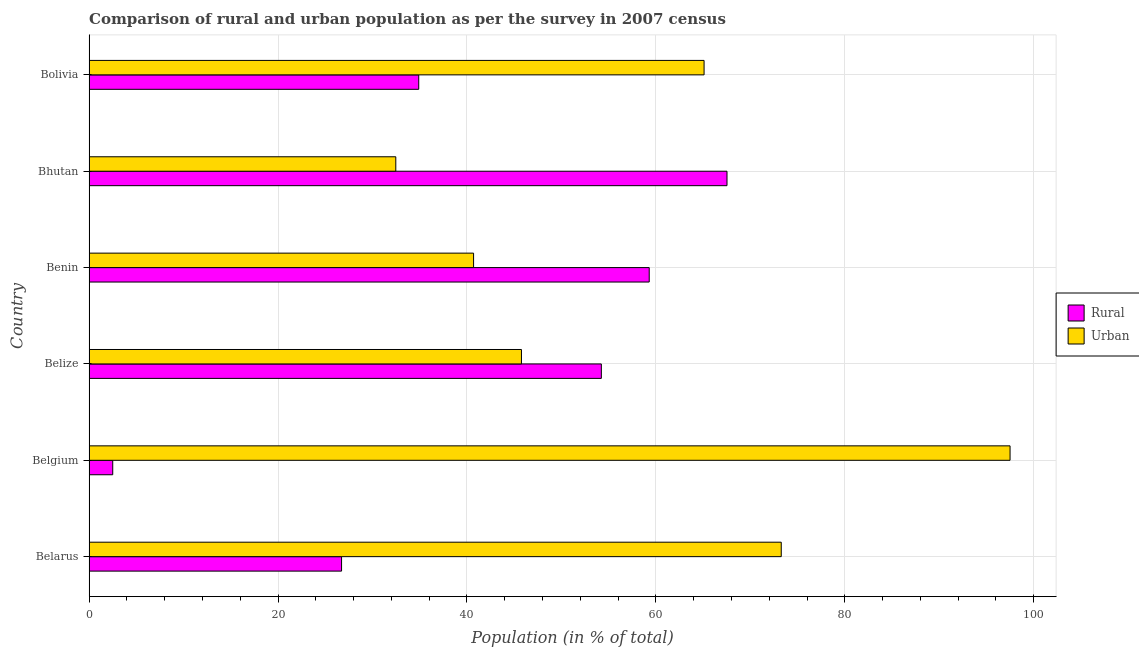How many different coloured bars are there?
Provide a succinct answer. 2. Are the number of bars per tick equal to the number of legend labels?
Offer a terse response. Yes. Are the number of bars on each tick of the Y-axis equal?
Keep it short and to the point. Yes. How many bars are there on the 1st tick from the top?
Provide a succinct answer. 2. What is the label of the 6th group of bars from the top?
Give a very brief answer. Belarus. What is the urban population in Belize?
Offer a very short reply. 45.77. Across all countries, what is the maximum urban population?
Ensure brevity in your answer.  97.5. Across all countries, what is the minimum rural population?
Your answer should be compact. 2.5. In which country was the rural population maximum?
Give a very brief answer. Bhutan. In which country was the urban population minimum?
Ensure brevity in your answer.  Bhutan. What is the total rural population in the graph?
Your answer should be very brief. 245.18. What is the difference between the rural population in Belize and that in Benin?
Make the answer very short. -5.07. What is the difference between the rural population in Bhutan and the urban population in Bolivia?
Offer a terse response. 2.43. What is the average urban population per country?
Make the answer very short. 59.14. What is the difference between the urban population and rural population in Belarus?
Offer a very short reply. 46.55. In how many countries, is the urban population greater than 32 %?
Keep it short and to the point. 6. What is the ratio of the urban population in Belgium to that in Belize?
Make the answer very short. 2.13. What is the difference between the highest and the second highest urban population?
Make the answer very short. 24.22. What is the difference between the highest and the lowest rural population?
Your response must be concise. 65.03. Is the sum of the rural population in Belarus and Belgium greater than the maximum urban population across all countries?
Provide a short and direct response. No. What does the 2nd bar from the top in Belarus represents?
Your answer should be very brief. Rural. What does the 2nd bar from the bottom in Bhutan represents?
Provide a short and direct response. Urban. Are all the bars in the graph horizontal?
Keep it short and to the point. Yes. How many countries are there in the graph?
Offer a very short reply. 6. What is the difference between two consecutive major ticks on the X-axis?
Offer a very short reply. 20. Are the values on the major ticks of X-axis written in scientific E-notation?
Your response must be concise. No. Does the graph contain any zero values?
Offer a terse response. No. Does the graph contain grids?
Your answer should be very brief. Yes. What is the title of the graph?
Make the answer very short. Comparison of rural and urban population as per the survey in 2007 census. What is the label or title of the X-axis?
Keep it short and to the point. Population (in % of total). What is the label or title of the Y-axis?
Provide a succinct answer. Country. What is the Population (in % of total) of Rural in Belarus?
Make the answer very short. 26.73. What is the Population (in % of total) in Urban in Belarus?
Your answer should be very brief. 73.27. What is the Population (in % of total) in Rural in Belgium?
Offer a terse response. 2.5. What is the Population (in % of total) of Urban in Belgium?
Offer a terse response. 97.5. What is the Population (in % of total) of Rural in Belize?
Your response must be concise. 54.23. What is the Population (in % of total) of Urban in Belize?
Your answer should be compact. 45.77. What is the Population (in % of total) in Rural in Benin?
Ensure brevity in your answer.  59.3. What is the Population (in % of total) of Urban in Benin?
Your response must be concise. 40.7. What is the Population (in % of total) in Rural in Bhutan?
Provide a succinct answer. 67.53. What is the Population (in % of total) of Urban in Bhutan?
Your response must be concise. 32.47. What is the Population (in % of total) in Rural in Bolivia?
Your answer should be compact. 34.9. What is the Population (in % of total) in Urban in Bolivia?
Keep it short and to the point. 65.1. Across all countries, what is the maximum Population (in % of total) of Rural?
Offer a terse response. 67.53. Across all countries, what is the maximum Population (in % of total) of Urban?
Give a very brief answer. 97.5. Across all countries, what is the minimum Population (in % of total) in Rural?
Give a very brief answer. 2.5. Across all countries, what is the minimum Population (in % of total) of Urban?
Give a very brief answer. 32.47. What is the total Population (in % of total) in Rural in the graph?
Your answer should be compact. 245.18. What is the total Population (in % of total) of Urban in the graph?
Provide a short and direct response. 354.82. What is the difference between the Population (in % of total) of Rural in Belarus and that in Belgium?
Provide a short and direct response. 24.22. What is the difference between the Population (in % of total) in Urban in Belarus and that in Belgium?
Make the answer very short. -24.22. What is the difference between the Population (in % of total) of Rural in Belarus and that in Belize?
Ensure brevity in your answer.  -27.5. What is the difference between the Population (in % of total) of Urban in Belarus and that in Belize?
Ensure brevity in your answer.  27.5. What is the difference between the Population (in % of total) in Rural in Belarus and that in Benin?
Offer a very short reply. -32.57. What is the difference between the Population (in % of total) of Urban in Belarus and that in Benin?
Provide a short and direct response. 32.57. What is the difference between the Population (in % of total) in Rural in Belarus and that in Bhutan?
Give a very brief answer. -40.8. What is the difference between the Population (in % of total) of Urban in Belarus and that in Bhutan?
Offer a very short reply. 40.8. What is the difference between the Population (in % of total) of Rural in Belarus and that in Bolivia?
Offer a terse response. -8.17. What is the difference between the Population (in % of total) in Urban in Belarus and that in Bolivia?
Offer a very short reply. 8.17. What is the difference between the Population (in % of total) in Rural in Belgium and that in Belize?
Make the answer very short. -51.73. What is the difference between the Population (in % of total) in Urban in Belgium and that in Belize?
Keep it short and to the point. 51.73. What is the difference between the Population (in % of total) of Rural in Belgium and that in Benin?
Offer a very short reply. -56.79. What is the difference between the Population (in % of total) of Urban in Belgium and that in Benin?
Your answer should be compact. 56.79. What is the difference between the Population (in % of total) in Rural in Belgium and that in Bhutan?
Provide a short and direct response. -65.03. What is the difference between the Population (in % of total) in Urban in Belgium and that in Bhutan?
Provide a succinct answer. 65.03. What is the difference between the Population (in % of total) in Rural in Belgium and that in Bolivia?
Provide a succinct answer. -32.39. What is the difference between the Population (in % of total) in Urban in Belgium and that in Bolivia?
Ensure brevity in your answer.  32.39. What is the difference between the Population (in % of total) of Rural in Belize and that in Benin?
Offer a very short reply. -5.07. What is the difference between the Population (in % of total) of Urban in Belize and that in Benin?
Offer a terse response. 5.07. What is the difference between the Population (in % of total) in Rural in Belize and that in Bhutan?
Offer a terse response. -13.3. What is the difference between the Population (in % of total) of Urban in Belize and that in Bhutan?
Offer a very short reply. 13.3. What is the difference between the Population (in % of total) of Rural in Belize and that in Bolivia?
Make the answer very short. 19.33. What is the difference between the Population (in % of total) in Urban in Belize and that in Bolivia?
Your response must be concise. -19.33. What is the difference between the Population (in % of total) of Rural in Benin and that in Bhutan?
Ensure brevity in your answer.  -8.23. What is the difference between the Population (in % of total) in Urban in Benin and that in Bhutan?
Offer a very short reply. 8.23. What is the difference between the Population (in % of total) in Rural in Benin and that in Bolivia?
Provide a short and direct response. 24.4. What is the difference between the Population (in % of total) in Urban in Benin and that in Bolivia?
Provide a succinct answer. -24.4. What is the difference between the Population (in % of total) in Rural in Bhutan and that in Bolivia?
Provide a succinct answer. 32.63. What is the difference between the Population (in % of total) of Urban in Bhutan and that in Bolivia?
Your answer should be compact. -32.63. What is the difference between the Population (in % of total) in Rural in Belarus and the Population (in % of total) in Urban in Belgium?
Provide a succinct answer. -70.77. What is the difference between the Population (in % of total) of Rural in Belarus and the Population (in % of total) of Urban in Belize?
Provide a short and direct response. -19.04. What is the difference between the Population (in % of total) of Rural in Belarus and the Population (in % of total) of Urban in Benin?
Offer a terse response. -13.98. What is the difference between the Population (in % of total) of Rural in Belarus and the Population (in % of total) of Urban in Bhutan?
Your answer should be compact. -5.74. What is the difference between the Population (in % of total) in Rural in Belarus and the Population (in % of total) in Urban in Bolivia?
Offer a terse response. -38.38. What is the difference between the Population (in % of total) of Rural in Belgium and the Population (in % of total) of Urban in Belize?
Provide a succinct answer. -43.27. What is the difference between the Population (in % of total) of Rural in Belgium and the Population (in % of total) of Urban in Benin?
Offer a very short reply. -38.2. What is the difference between the Population (in % of total) in Rural in Belgium and the Population (in % of total) in Urban in Bhutan?
Offer a very short reply. -29.97. What is the difference between the Population (in % of total) in Rural in Belgium and the Population (in % of total) in Urban in Bolivia?
Offer a terse response. -62.6. What is the difference between the Population (in % of total) of Rural in Belize and the Population (in % of total) of Urban in Benin?
Offer a terse response. 13.53. What is the difference between the Population (in % of total) of Rural in Belize and the Population (in % of total) of Urban in Bhutan?
Ensure brevity in your answer.  21.76. What is the difference between the Population (in % of total) of Rural in Belize and the Population (in % of total) of Urban in Bolivia?
Ensure brevity in your answer.  -10.88. What is the difference between the Population (in % of total) of Rural in Benin and the Population (in % of total) of Urban in Bhutan?
Give a very brief answer. 26.83. What is the difference between the Population (in % of total) of Rural in Benin and the Population (in % of total) of Urban in Bolivia?
Your answer should be very brief. -5.81. What is the difference between the Population (in % of total) of Rural in Bhutan and the Population (in % of total) of Urban in Bolivia?
Your response must be concise. 2.43. What is the average Population (in % of total) of Rural per country?
Ensure brevity in your answer.  40.86. What is the average Population (in % of total) in Urban per country?
Give a very brief answer. 59.14. What is the difference between the Population (in % of total) of Rural and Population (in % of total) of Urban in Belarus?
Make the answer very short. -46.55. What is the difference between the Population (in % of total) in Rural and Population (in % of total) in Urban in Belgium?
Give a very brief answer. -94.99. What is the difference between the Population (in % of total) of Rural and Population (in % of total) of Urban in Belize?
Provide a short and direct response. 8.46. What is the difference between the Population (in % of total) of Rural and Population (in % of total) of Urban in Benin?
Provide a succinct answer. 18.59. What is the difference between the Population (in % of total) of Rural and Population (in % of total) of Urban in Bhutan?
Your answer should be very brief. 35.06. What is the difference between the Population (in % of total) of Rural and Population (in % of total) of Urban in Bolivia?
Offer a very short reply. -30.21. What is the ratio of the Population (in % of total) in Rural in Belarus to that in Belgium?
Provide a succinct answer. 10.68. What is the ratio of the Population (in % of total) of Urban in Belarus to that in Belgium?
Provide a short and direct response. 0.75. What is the ratio of the Population (in % of total) in Rural in Belarus to that in Belize?
Offer a terse response. 0.49. What is the ratio of the Population (in % of total) of Urban in Belarus to that in Belize?
Ensure brevity in your answer.  1.6. What is the ratio of the Population (in % of total) of Rural in Belarus to that in Benin?
Make the answer very short. 0.45. What is the ratio of the Population (in % of total) of Urban in Belarus to that in Benin?
Ensure brevity in your answer.  1.8. What is the ratio of the Population (in % of total) of Rural in Belarus to that in Bhutan?
Your answer should be compact. 0.4. What is the ratio of the Population (in % of total) of Urban in Belarus to that in Bhutan?
Offer a very short reply. 2.26. What is the ratio of the Population (in % of total) in Rural in Belarus to that in Bolivia?
Make the answer very short. 0.77. What is the ratio of the Population (in % of total) of Urban in Belarus to that in Bolivia?
Keep it short and to the point. 1.13. What is the ratio of the Population (in % of total) of Rural in Belgium to that in Belize?
Offer a very short reply. 0.05. What is the ratio of the Population (in % of total) of Urban in Belgium to that in Belize?
Give a very brief answer. 2.13. What is the ratio of the Population (in % of total) in Rural in Belgium to that in Benin?
Provide a succinct answer. 0.04. What is the ratio of the Population (in % of total) in Urban in Belgium to that in Benin?
Your response must be concise. 2.4. What is the ratio of the Population (in % of total) of Rural in Belgium to that in Bhutan?
Offer a terse response. 0.04. What is the ratio of the Population (in % of total) of Urban in Belgium to that in Bhutan?
Keep it short and to the point. 3. What is the ratio of the Population (in % of total) in Rural in Belgium to that in Bolivia?
Offer a terse response. 0.07. What is the ratio of the Population (in % of total) in Urban in Belgium to that in Bolivia?
Make the answer very short. 1.5. What is the ratio of the Population (in % of total) in Rural in Belize to that in Benin?
Keep it short and to the point. 0.91. What is the ratio of the Population (in % of total) of Urban in Belize to that in Benin?
Make the answer very short. 1.12. What is the ratio of the Population (in % of total) in Rural in Belize to that in Bhutan?
Offer a very short reply. 0.8. What is the ratio of the Population (in % of total) of Urban in Belize to that in Bhutan?
Offer a terse response. 1.41. What is the ratio of the Population (in % of total) of Rural in Belize to that in Bolivia?
Provide a short and direct response. 1.55. What is the ratio of the Population (in % of total) in Urban in Belize to that in Bolivia?
Your answer should be very brief. 0.7. What is the ratio of the Population (in % of total) of Rural in Benin to that in Bhutan?
Provide a short and direct response. 0.88. What is the ratio of the Population (in % of total) of Urban in Benin to that in Bhutan?
Offer a terse response. 1.25. What is the ratio of the Population (in % of total) in Rural in Benin to that in Bolivia?
Keep it short and to the point. 1.7. What is the ratio of the Population (in % of total) of Urban in Benin to that in Bolivia?
Your response must be concise. 0.63. What is the ratio of the Population (in % of total) in Rural in Bhutan to that in Bolivia?
Your answer should be compact. 1.94. What is the ratio of the Population (in % of total) of Urban in Bhutan to that in Bolivia?
Make the answer very short. 0.5. What is the difference between the highest and the second highest Population (in % of total) in Rural?
Your answer should be compact. 8.23. What is the difference between the highest and the second highest Population (in % of total) in Urban?
Provide a succinct answer. 24.22. What is the difference between the highest and the lowest Population (in % of total) of Rural?
Offer a terse response. 65.03. What is the difference between the highest and the lowest Population (in % of total) of Urban?
Provide a short and direct response. 65.03. 